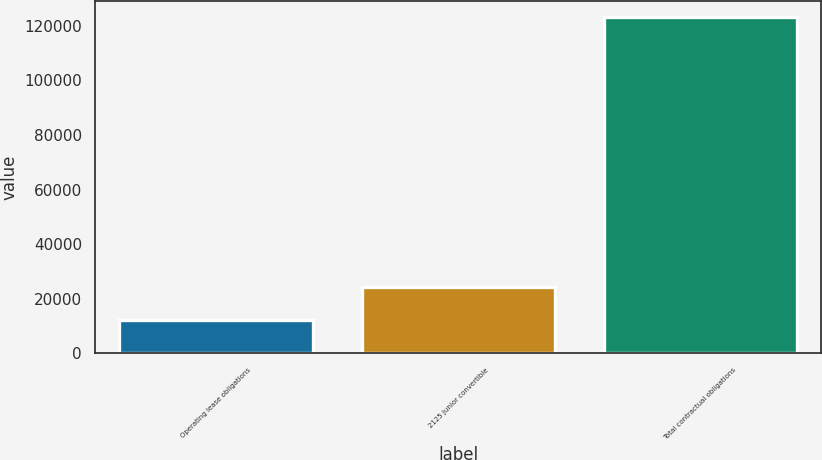<chart> <loc_0><loc_0><loc_500><loc_500><bar_chart><fcel>Operating lease obligations<fcel>2125 junior convertible<fcel>Total contractual obligations<nl><fcel>12415<fcel>24438<fcel>123003<nl></chart> 